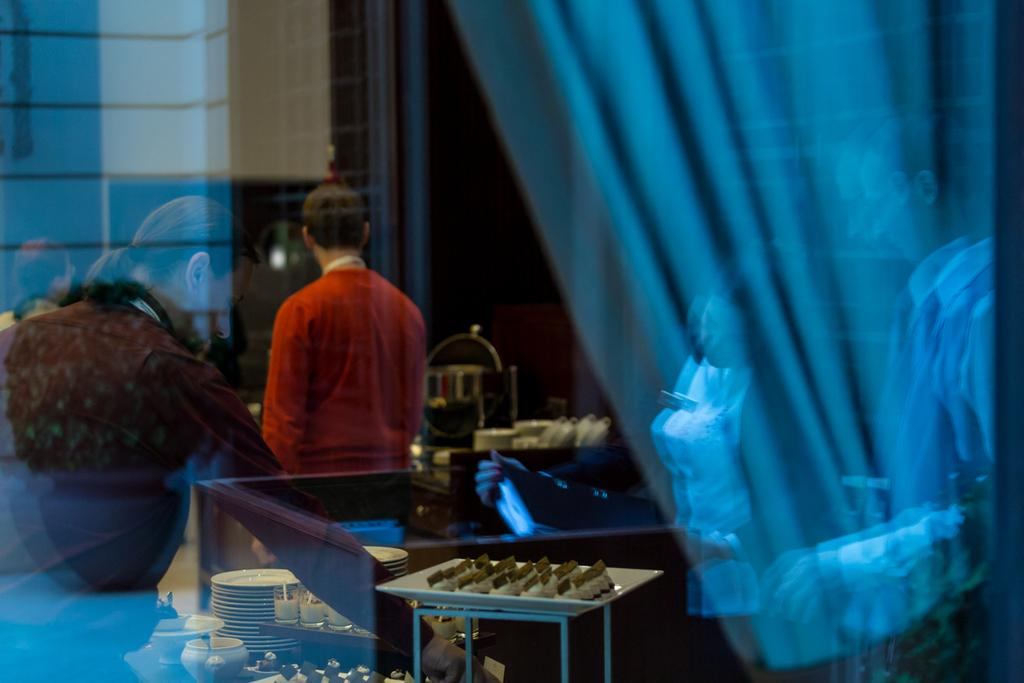What can be seen in the image? There are people standing in the image. What else is visible besides the people? There are plates and cups in the image. Are there any other objects present? Yes, there are other objects in the image. What can be seen in the background of the image? There is a wall in the background of the image. Can you tell me what the grandmother is regretting in the image? There is no grandmother or any indication of regret present in the image. 